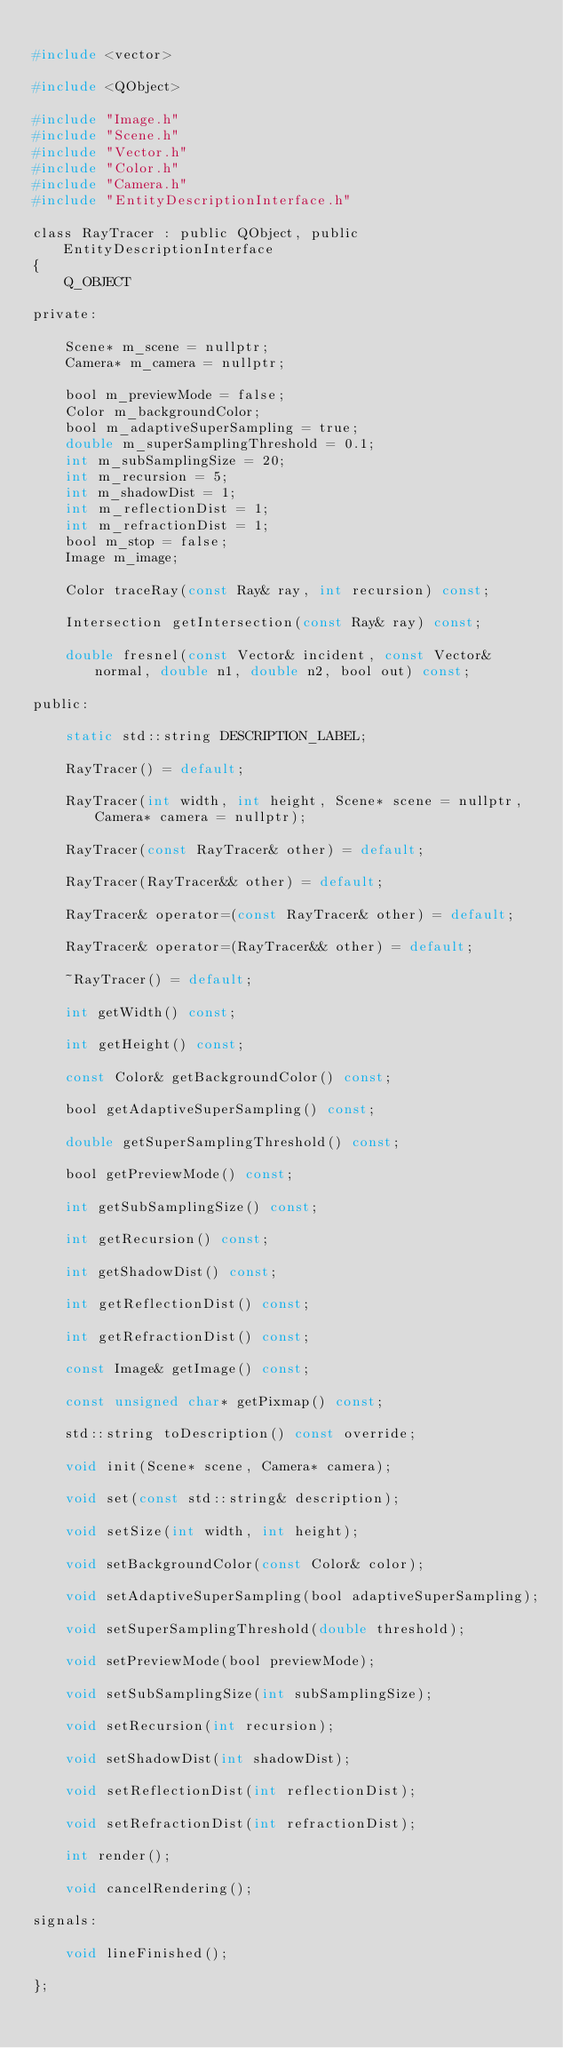Convert code to text. <code><loc_0><loc_0><loc_500><loc_500><_C_>
#include <vector>

#include <QObject>

#include "Image.h"
#include "Scene.h"
#include "Vector.h"
#include "Color.h"
#include "Camera.h"
#include "EntityDescriptionInterface.h"

class RayTracer : public QObject, public EntityDescriptionInterface
{
    Q_OBJECT

private:

	Scene* m_scene = nullptr;
	Camera* m_camera = nullptr;

    bool m_previewMode = false;
	Color m_backgroundColor;
    bool m_adaptiveSuperSampling = true;
    double m_superSamplingThreshold = 0.1;
    int m_subSamplingSize = 20;
    int m_recursion = 5;
    int m_shadowDist = 1;
    int m_reflectionDist = 1;
    int m_refractionDist = 1;
    bool m_stop = false;
    Image m_image;

    Color traceRay(const Ray& ray, int recursion) const;

    Intersection getIntersection(const Ray& ray) const;

    double fresnel(const Vector& incident, const Vector& normal, double n1, double n2, bool out) const;

public:

	static std::string DESCRIPTION_LABEL;

    RayTracer() = default;

    RayTracer(int width, int height, Scene* scene = nullptr, Camera* camera = nullptr);

	RayTracer(const RayTracer& other) = default;

	RayTracer(RayTracer&& other) = default;

	RayTracer& operator=(const RayTracer& other) = default;

	RayTracer& operator=(RayTracer&& other) = default;

	~RayTracer() = default;

    int getWidth() const;

    int getHeight() const;

	const Color& getBackgroundColor() const;

    bool getAdaptiveSuperSampling() const;

    double getSuperSamplingThreshold() const;

    bool getPreviewMode() const;

    int getSubSamplingSize() const;

    int getRecursion() const;

    int getShadowDist() const;

    int getReflectionDist() const;

    int getRefractionDist() const;

    const Image& getImage() const;

    const unsigned char* getPixmap() const;

	std::string toDescription() const override;

	void init(Scene* scene, Camera* camera);

	void set(const std::string& description);

    void setSize(int width, int height);

	void setBackgroundColor(const Color& color);

    void setAdaptiveSuperSampling(bool adaptiveSuperSampling);

    void setSuperSamplingThreshold(double threshold);

    void setPreviewMode(bool previewMode);

    void setSubSamplingSize(int subSamplingSize);

    void setRecursion(int recursion);

    void setShadowDist(int shadowDist);

    void setReflectionDist(int reflectionDist);

    void setRefractionDist(int refractionDist);

    int render();

    void cancelRendering();

signals:

    void lineFinished();

};
</code> 